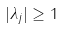<formula> <loc_0><loc_0><loc_500><loc_500>| \lambda _ { j } | \geq 1</formula> 